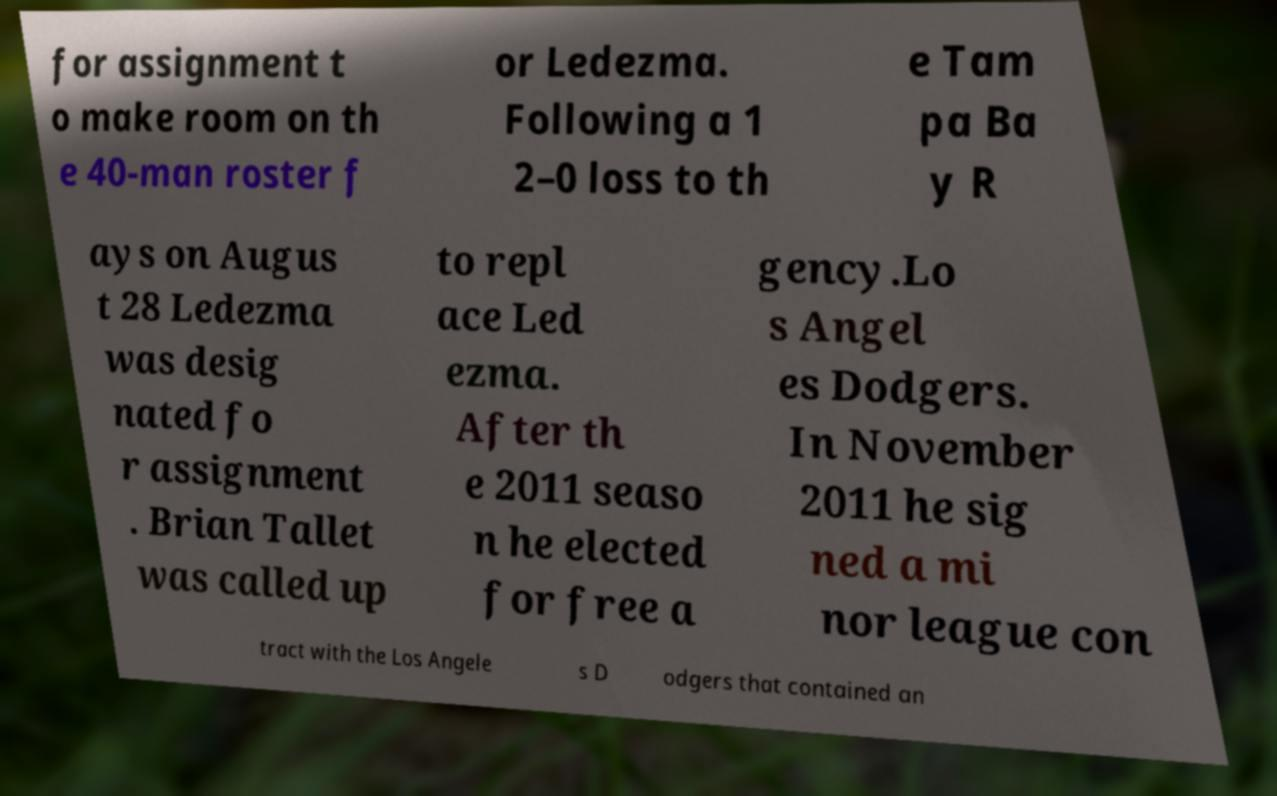Please identify and transcribe the text found in this image. for assignment t o make room on th e 40-man roster f or Ledezma. Following a 1 2–0 loss to th e Tam pa Ba y R ays on Augus t 28 Ledezma was desig nated fo r assignment . Brian Tallet was called up to repl ace Led ezma. After th e 2011 seaso n he elected for free a gency.Lo s Angel es Dodgers. In November 2011 he sig ned a mi nor league con tract with the Los Angele s D odgers that contained an 